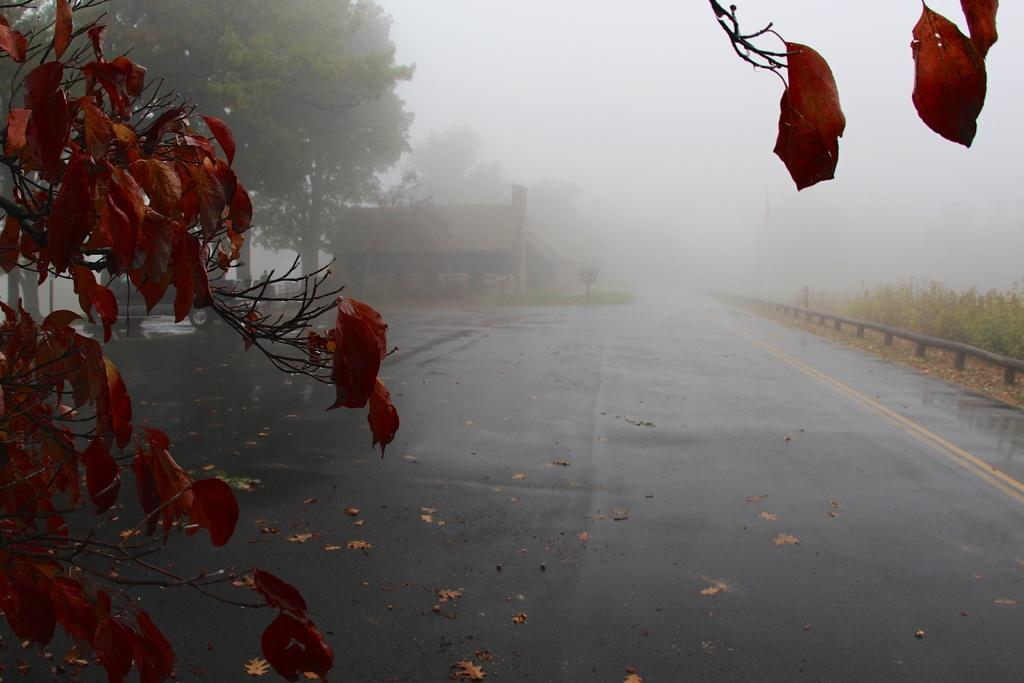What is the condition of the road in the image? The road is wet in the image. What safety feature can be seen on the road in the image? There is a road barrier in the image. What type of vegetation is present in the image? There are plants and trees in the image. What additional detail can be observed on the ground in the image? Dry leaves are visible in the image. What type of structure is visible in the image? There is a house in the image. What atmospheric condition is present in the image? There is a smoky cloud in the image. Where is the face of the person attending the meeting in the image? There is no face or meeting present in the image. What type of acoustics can be heard in the image? The image does not depict any sounds or acoustics; it is a still image. 